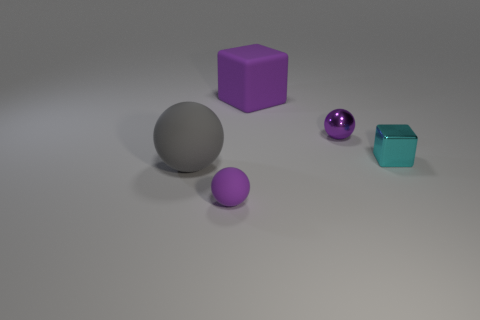Subtract all purple spheres. How many spheres are left? 1 Subtract all brown blocks. How many purple balls are left? 2 Add 3 gray objects. How many objects exist? 8 Subtract all cubes. How many objects are left? 3 Subtract 0 purple cylinders. How many objects are left? 5 Subtract all yellow blocks. Subtract all cyan cylinders. How many blocks are left? 2 Subtract all purple cubes. Subtract all small purple matte things. How many objects are left? 3 Add 3 large gray rubber spheres. How many large gray rubber spheres are left? 4 Add 4 large green metal balls. How many large green metal balls exist? 4 